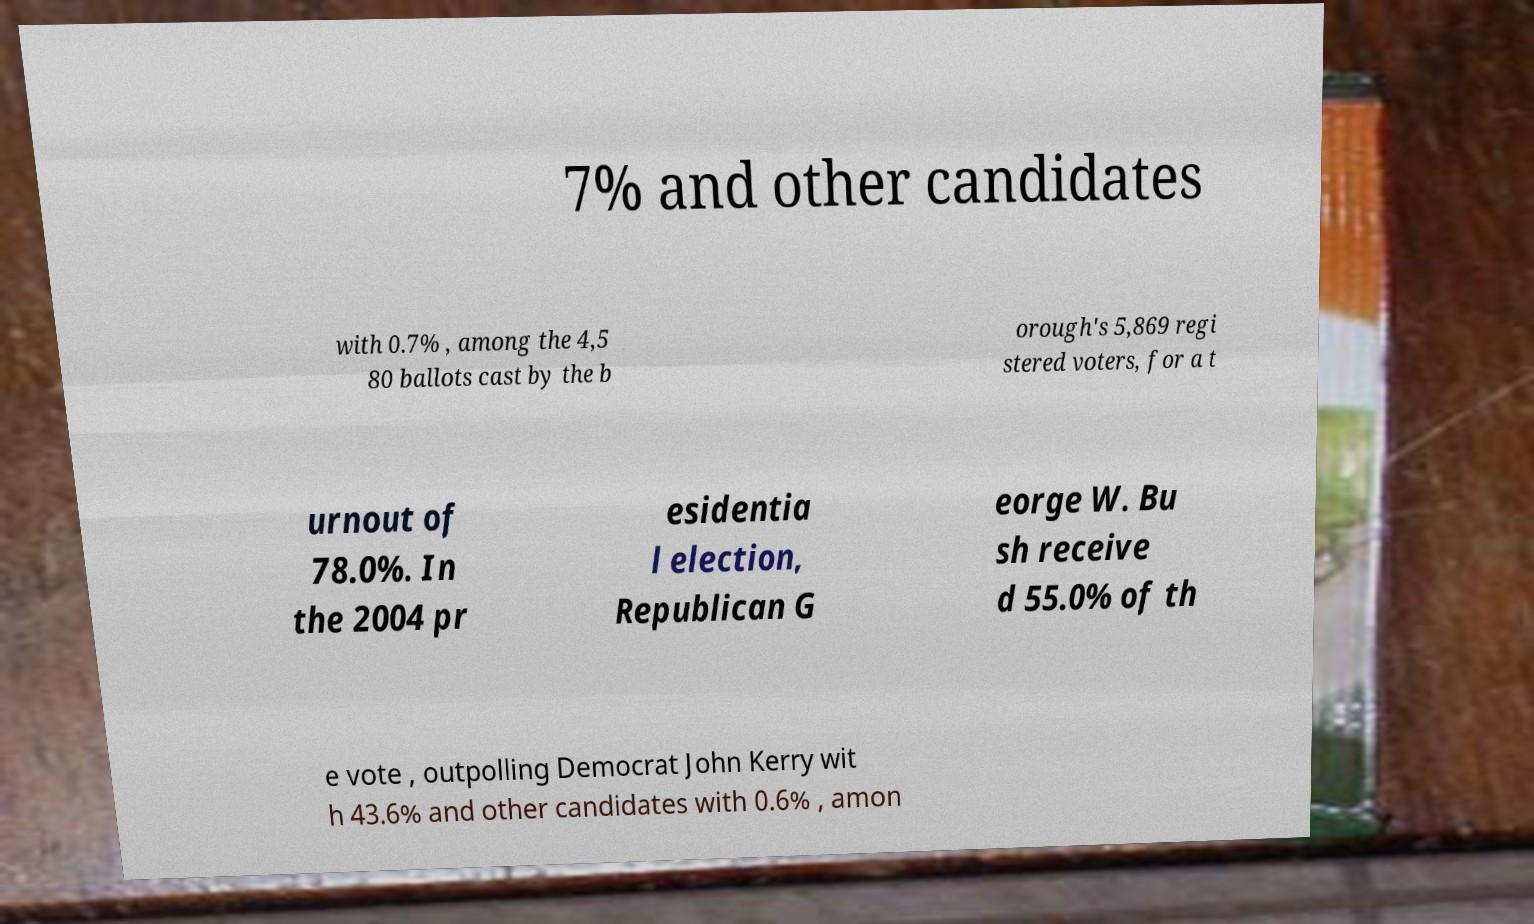For documentation purposes, I need the text within this image transcribed. Could you provide that? 7% and other candidates with 0.7% , among the 4,5 80 ballots cast by the b orough's 5,869 regi stered voters, for a t urnout of 78.0%. In the 2004 pr esidentia l election, Republican G eorge W. Bu sh receive d 55.0% of th e vote , outpolling Democrat John Kerry wit h 43.6% and other candidates with 0.6% , amon 